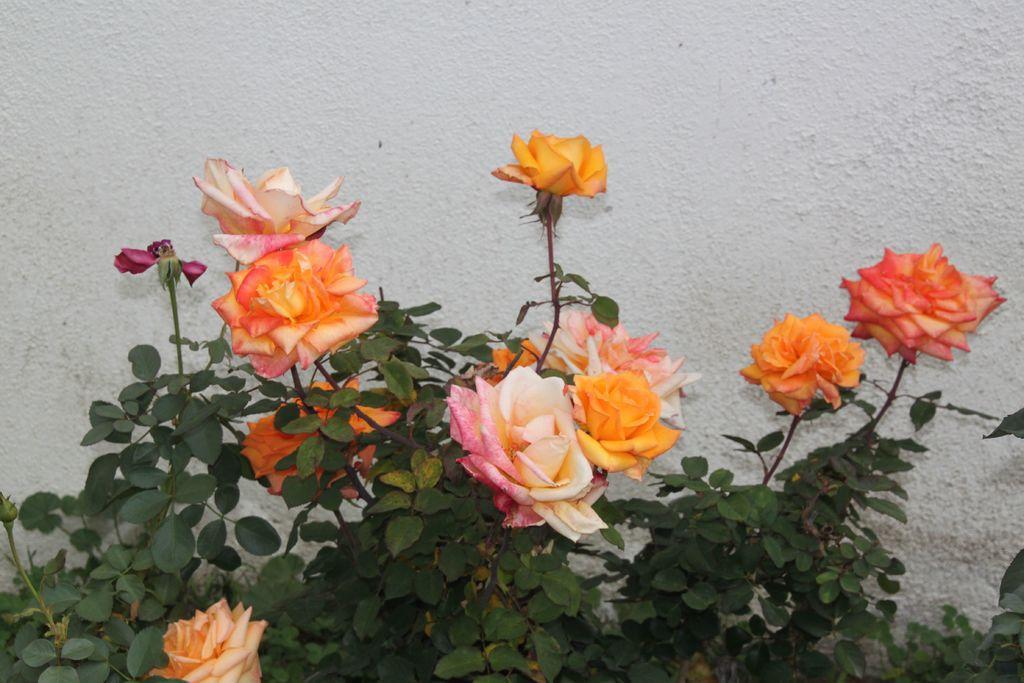Describe this image in one or two sentences. In the front of the image there are rose plants. In the background of the image there is a wall. 